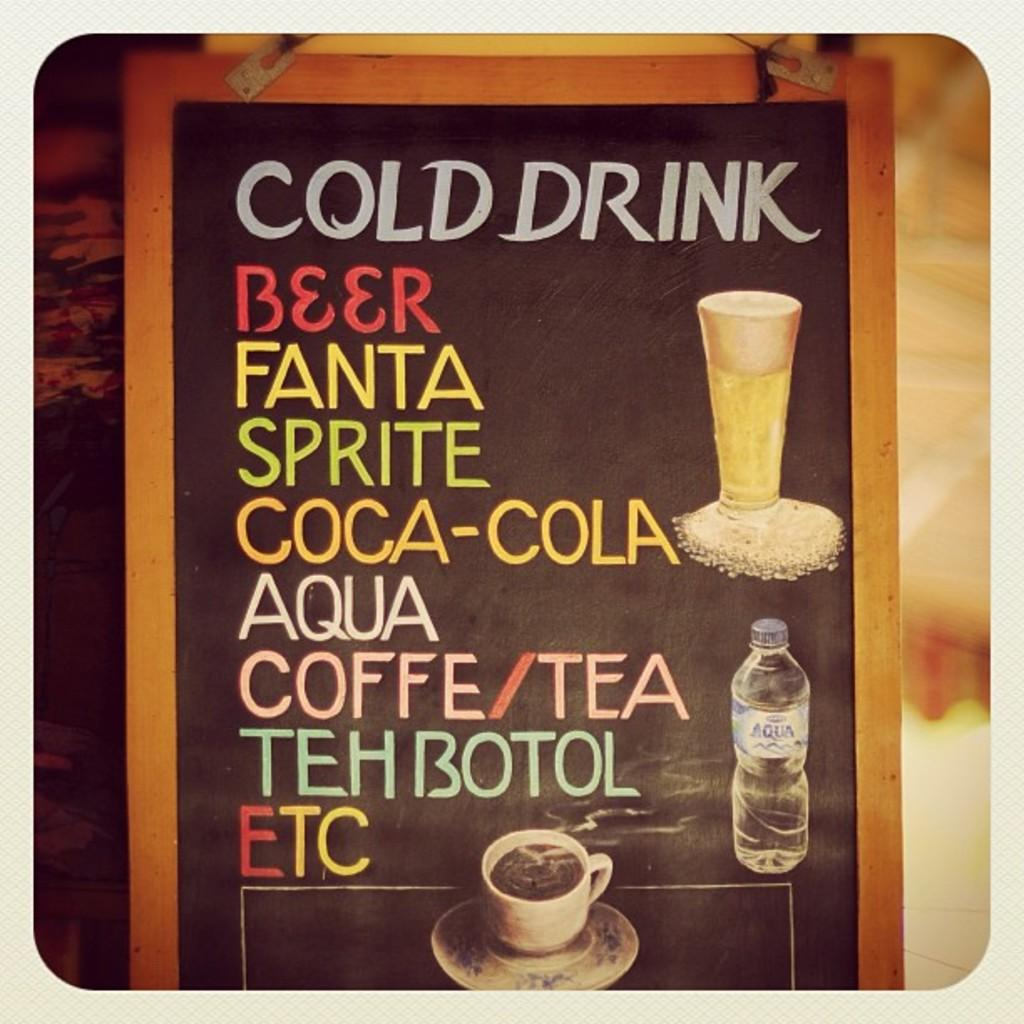Provide a one-sentence caption for the provided image. A board that is advertising various cold drinks also shows that coffee and tea are available. 